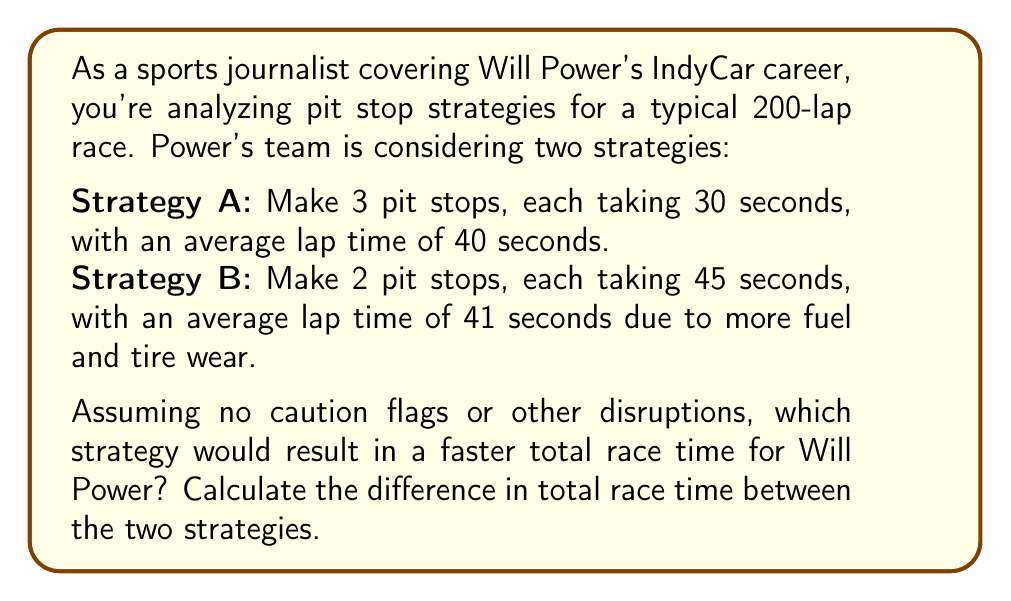Can you answer this question? Let's break this down step-by-step:

1) First, let's calculate the total race time for Strategy A:

   Laps without pit stops: 200 - 3 = 197 laps
   Time for regular laps: 197 * 40 seconds = 7880 seconds
   Time for pit stops: 3 * 30 seconds = 90 seconds
   Total time A = 7880 + 90 = 7970 seconds

2) Now, let's calculate the total race time for Strategy B:

   Laps without pit stops: 200 - 2 = 198 laps
   Time for regular laps: 198 * 41 seconds = 8118 seconds
   Time for pit stops: 2 * 45 seconds = 90 seconds
   Total time B = 8118 + 90 = 8208 seconds

3) To find the difference, we subtract:

   Difference = Total time B - Total time A
               = 8208 - 7970 = 238 seconds

Therefore, Strategy A is faster by 238 seconds, or 3 minutes and 58 seconds.

The expected value (EV) of each strategy in terms of race time is:

$$EV(\text{Strategy A}) = 7970\text{ seconds}$$
$$EV(\text{Strategy B}) = 8208\text{ seconds}$$

Strategy A has a lower expected race time, making it the better choice in this scenario.
Answer: Strategy A is faster by 238 seconds (3 minutes and 58 seconds). 